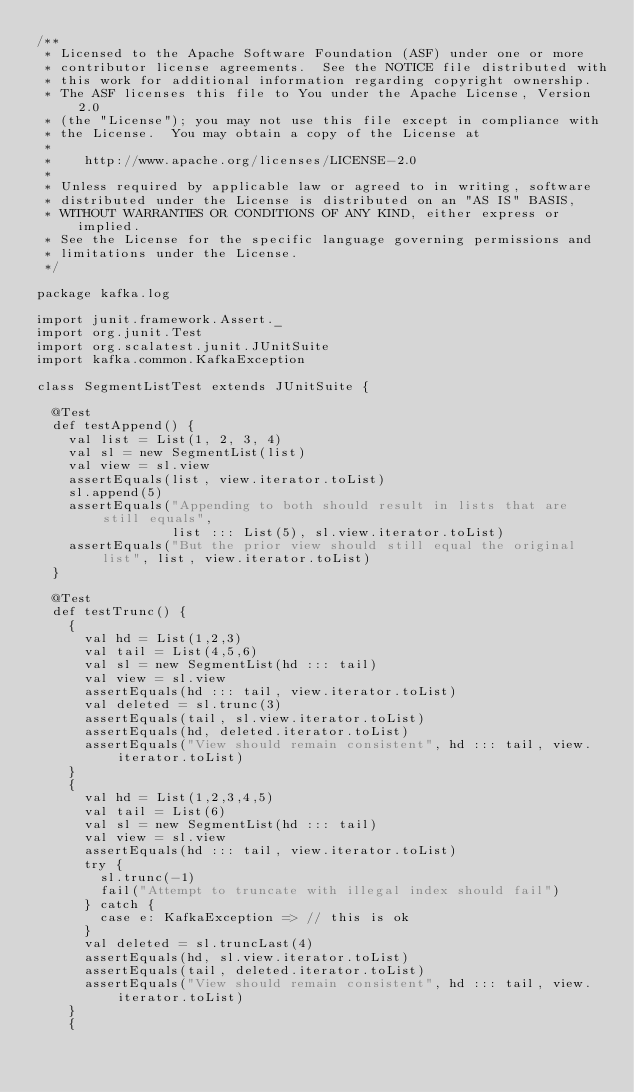Convert code to text. <code><loc_0><loc_0><loc_500><loc_500><_Scala_>/**
 * Licensed to the Apache Software Foundation (ASF) under one or more
 * contributor license agreements.  See the NOTICE file distributed with
 * this work for additional information regarding copyright ownership.
 * The ASF licenses this file to You under the Apache License, Version 2.0
 * (the "License"); you may not use this file except in compliance with
 * the License.  You may obtain a copy of the License at
 * 
 *    http://www.apache.org/licenses/LICENSE-2.0
 *
 * Unless required by applicable law or agreed to in writing, software
 * distributed under the License is distributed on an "AS IS" BASIS,
 * WITHOUT WARRANTIES OR CONDITIONS OF ANY KIND, either express or implied.
 * See the License for the specific language governing permissions and
 * limitations under the License.
 */

package kafka.log

import junit.framework.Assert._
import org.junit.Test
import org.scalatest.junit.JUnitSuite
import kafka.common.KafkaException

class SegmentListTest extends JUnitSuite {

  @Test
  def testAppend() {
    val list = List(1, 2, 3, 4)
    val sl = new SegmentList(list)
    val view = sl.view
    assertEquals(list, view.iterator.toList)
    sl.append(5)
    assertEquals("Appending to both should result in lists that are still equals",
                 list ::: List(5), sl.view.iterator.toList)
    assertEquals("But the prior view should still equal the original list", list, view.iterator.toList)
  }
  
  @Test
  def testTrunc() {
    {
      val hd = List(1,2,3)
      val tail = List(4,5,6)
      val sl = new SegmentList(hd ::: tail)
      val view = sl.view
      assertEquals(hd ::: tail, view.iterator.toList)
      val deleted = sl.trunc(3)
      assertEquals(tail, sl.view.iterator.toList)
      assertEquals(hd, deleted.iterator.toList)
      assertEquals("View should remain consistent", hd ::: tail, view.iterator.toList)
    }
    {
      val hd = List(1,2,3,4,5)
      val tail = List(6)
      val sl = new SegmentList(hd ::: tail)
      val view = sl.view
      assertEquals(hd ::: tail, view.iterator.toList)
      try {
        sl.trunc(-1)
        fail("Attempt to truncate with illegal index should fail")
      } catch {
        case e: KafkaException => // this is ok
      }
      val deleted = sl.truncLast(4)
      assertEquals(hd, sl.view.iterator.toList)
      assertEquals(tail, deleted.iterator.toList)
      assertEquals("View should remain consistent", hd ::: tail, view.iterator.toList)
    }
    {</code> 